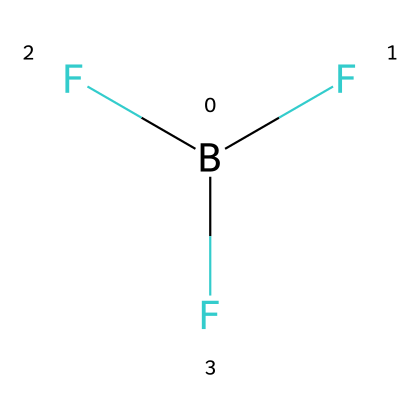How many total atoms are present in boron trifluoride? The chemical structure indicates one boron atom and three fluorine atoms. Adding these gives a total of 1 + 3 = 4 atoms.
Answer: 4 What is the central atom in the structure of boron trifluoride? Looking at the SMILES representation, the "B" indicates that boron is the central atom, surrounded by three fluorine atoms.
Answer: boron How many fluorine atoms are bonded to the boron atom? The SMILES representation contains "F" three times, indicating three fluorine atoms are directly bonded to the central boron atom.
Answer: 3 What type of molecular geometry does boron trifluoride exhibit? Boron trifluoride has a trigonal planar geometry, which is determined by the presence of three bonding pairs around the central boron without lone pairs.
Answer: trigonal planar Is boron trifluoride considered a strong or weak Lewis acid? Boron has an incomplete octet which means it can accept electron pairs easily, classifying boron trifluoride as a strong Lewis acid.
Answer: strong What role does boron trifluoride play in plants? Boron trifluoride, as a plant growth regulator, is involved in processes such as cell division and elongation, promoting growth.
Answer: growth regulator 